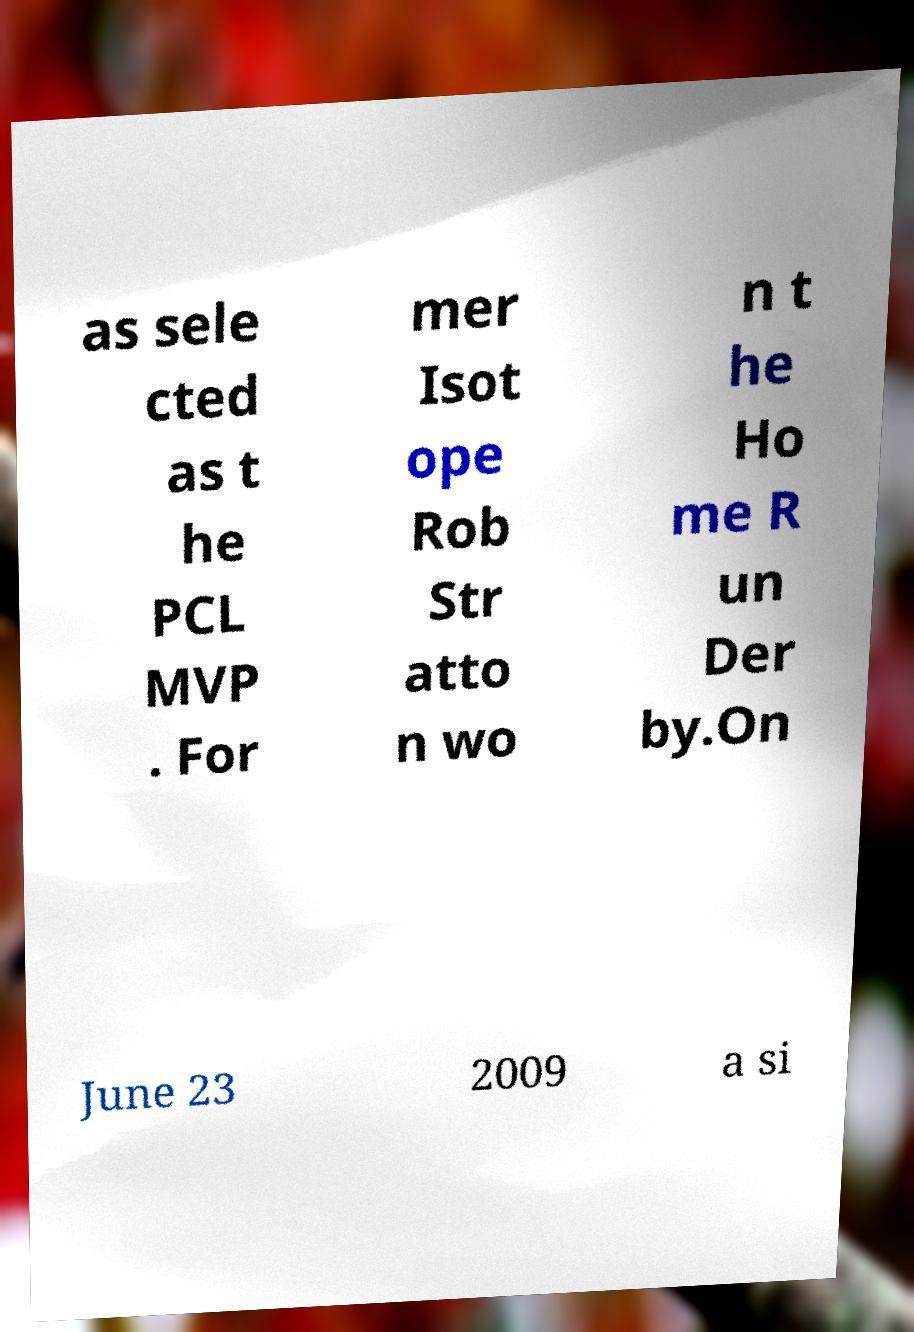For documentation purposes, I need the text within this image transcribed. Could you provide that? as sele cted as t he PCL MVP . For mer Isot ope Rob Str atto n wo n t he Ho me R un Der by.On June 23 2009 a si 